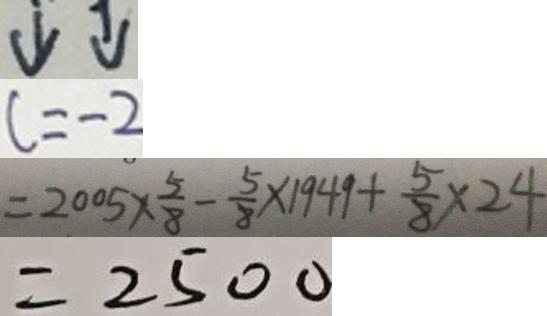Convert formula to latex. <formula><loc_0><loc_0><loc_500><loc_500>\downarrow \downarrow 
 c = - 2 
 = 2 0 0 5 \times \frac { 5 } { 8 } - \frac { 5 } { 8 } \times 1 9 4 9 + \frac { 5 } { 8 } \times 2 4 
 = 2 5 0 0</formula> 